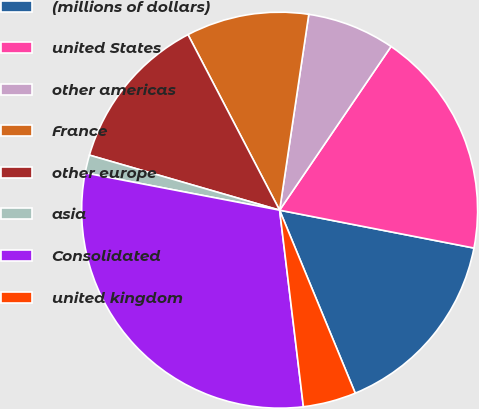<chart> <loc_0><loc_0><loc_500><loc_500><pie_chart><fcel>(millions of dollars)<fcel>united States<fcel>other americas<fcel>France<fcel>other europe<fcel>asia<fcel>Consolidated<fcel>united kingdom<nl><fcel>15.7%<fcel>18.55%<fcel>7.16%<fcel>10.01%<fcel>12.86%<fcel>1.47%<fcel>29.93%<fcel>4.32%<nl></chart> 